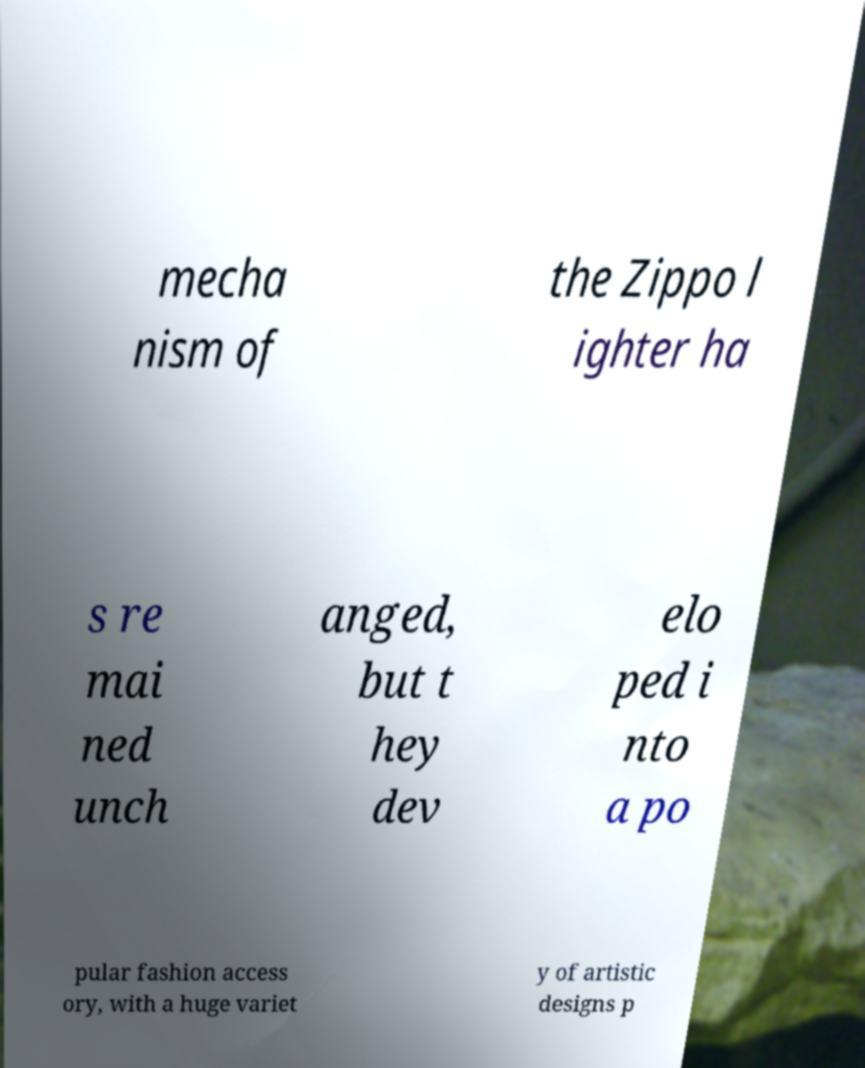There's text embedded in this image that I need extracted. Can you transcribe it verbatim? mecha nism of the Zippo l ighter ha s re mai ned unch anged, but t hey dev elo ped i nto a po pular fashion access ory, with a huge variet y of artistic designs p 